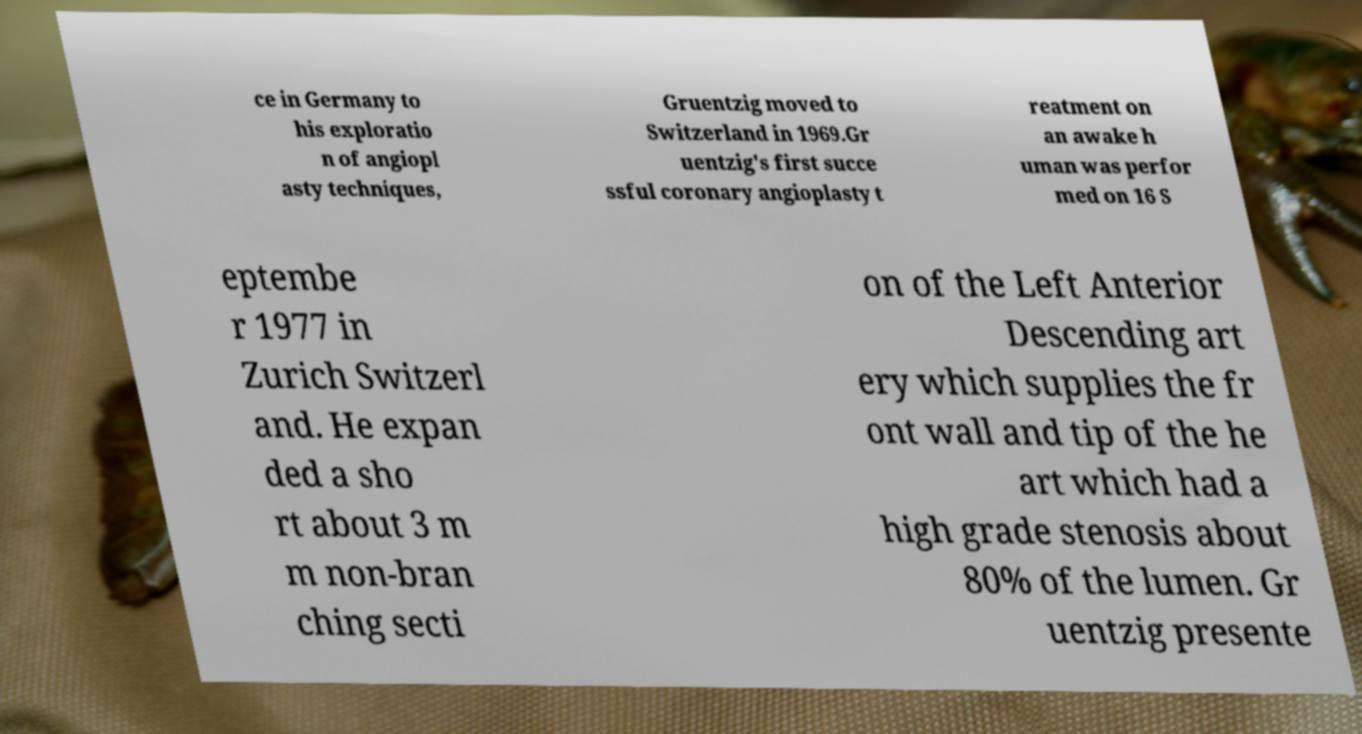Please read and relay the text visible in this image. What does it say? ce in Germany to his exploratio n of angiopl asty techniques, Gruentzig moved to Switzerland in 1969.Gr uentzig's first succe ssful coronary angioplasty t reatment on an awake h uman was perfor med on 16 S eptembe r 1977 in Zurich Switzerl and. He expan ded a sho rt about 3 m m non-bran ching secti on of the Left Anterior Descending art ery which supplies the fr ont wall and tip of the he art which had a high grade stenosis about 80% of the lumen. Gr uentzig presente 